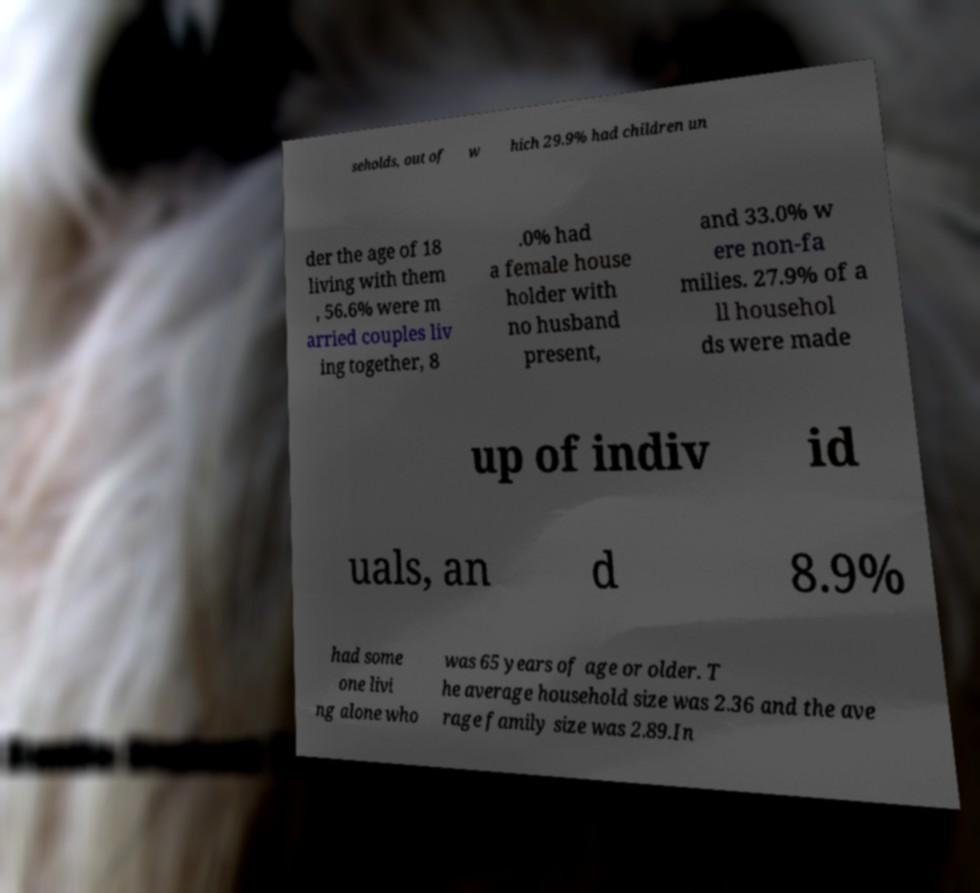Can you accurately transcribe the text from the provided image for me? seholds, out of w hich 29.9% had children un der the age of 18 living with them , 56.6% were m arried couples liv ing together, 8 .0% had a female house holder with no husband present, and 33.0% w ere non-fa milies. 27.9% of a ll househol ds were made up of indiv id uals, an d 8.9% had some one livi ng alone who was 65 years of age or older. T he average household size was 2.36 and the ave rage family size was 2.89.In 